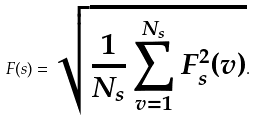Convert formula to latex. <formula><loc_0><loc_0><loc_500><loc_500>F ( s ) = \sqrt { \frac { 1 } { N _ { s } } \sum _ { v = 1 } ^ { N _ { s } } F _ { s } ^ { 2 } ( v ) } .</formula> 